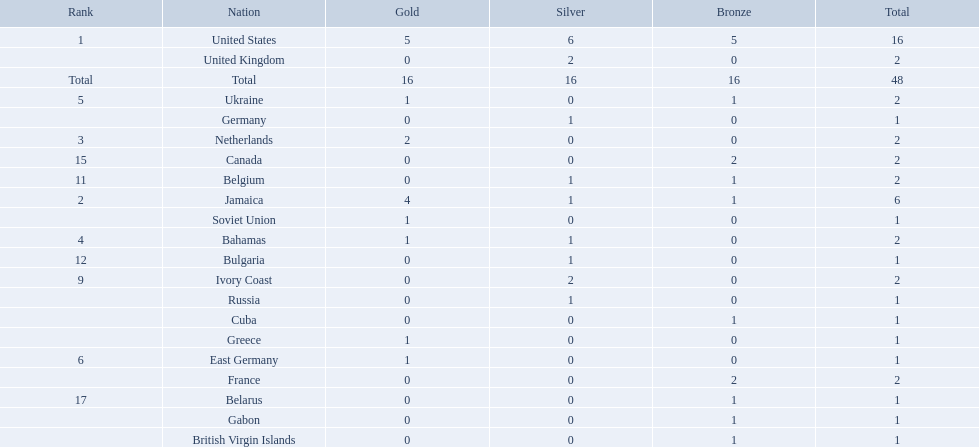What was the largest number of medals won by any country? 16. Which country won that many medals? United States. 